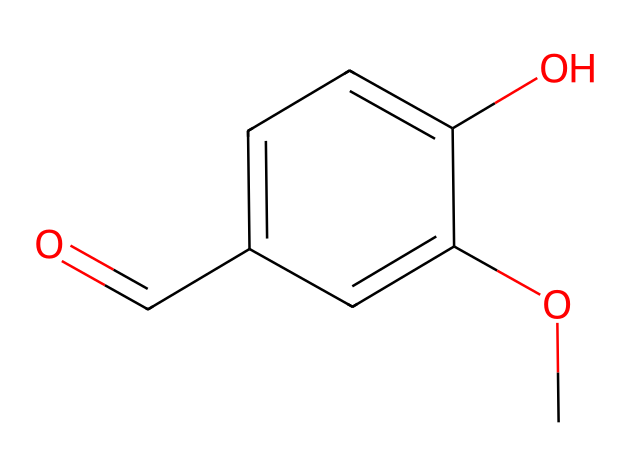how many carbon atoms are in this compound? By analyzing the SMILES representation, there are five 'C' characters present, which indicates five carbon atoms in the structure.
Answer: five what is the functional group present in this compound? The chemical structure includes a carbonyl group (C=O) and a hydroxyl group (–OH). The carbonyl and hydroxyl are significant functional groups of this compound.
Answer: carbonyl and hydroxyl how many oxygen atoms are in this compound? In the SMILES representation, there are two 'O' characters specifying the presence of two oxygen atoms in the structure.
Answer: two which aromatic rings are present in this compound? The structure contains a single benzene ring, denoted by 'c' in the SMILES, which represents aromatic carbon atoms.
Answer: one what is the molecular formula of this compound? Counting the number of each type of atom based on the SMILES gives C8H8O3 as the molecular formula (8 carbons, 8 hydrogens, 3 oxygens).
Answer: C8H8O3 what type of compound is this? Given that this compound has a benzene ring and functional groups, it is classified as an aromatic compound, particularly a phenolic compound due to the presence of the hydroxyl group.
Answer: aromatic compound how does this compound's structure contribute to its sweetness? Vanillin contains a particular arrangement of atoms and functional groups leading to its sweet aroma and flavor. The presence of the hydroxyl group allows for interactions with taste receptors, enhancing the sweetness perception.
Answer: hydroxyl group 